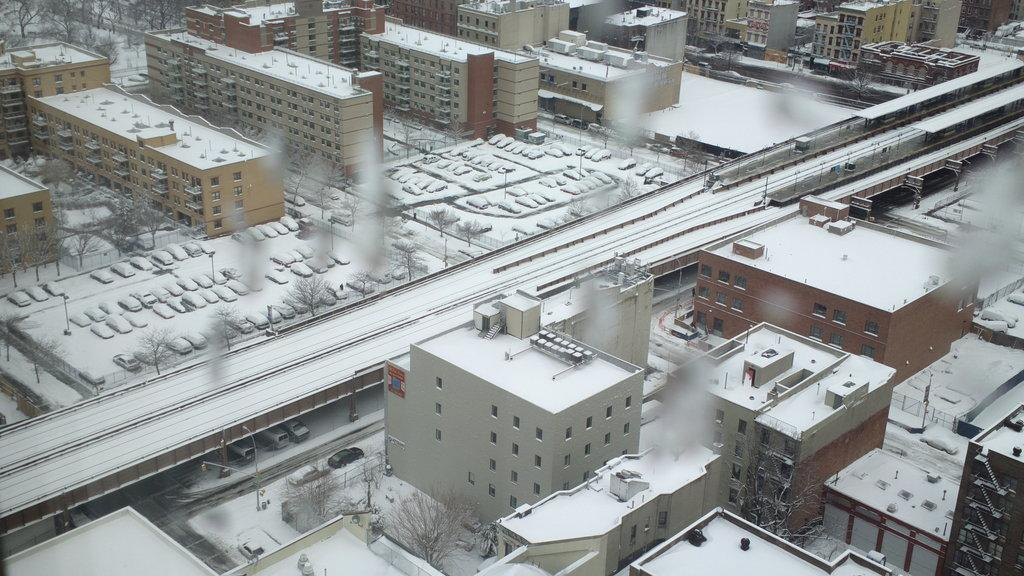What type of structures can be seen in the image? There are buildings with windows in the image. What vehicles are present in the image? There are cars parked aside in the image. What type of vegetation is visible in the image? There are trees in the image. What architectural feature is present in the image? There is a bridge in the image. Where is the zoo located in the image? There is no zoo present in the image. What type of sticks are used to build the buildings in the image? The buildings in the image are not made of sticks; they are made of other materials. 